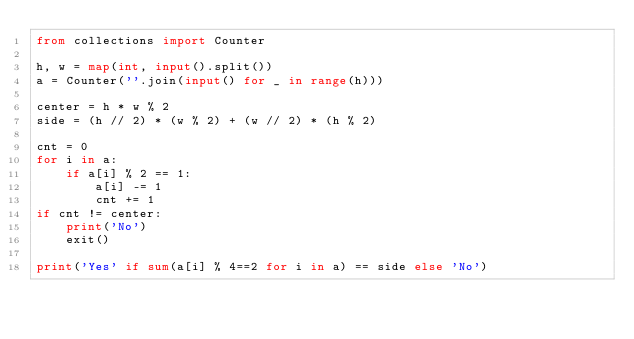Convert code to text. <code><loc_0><loc_0><loc_500><loc_500><_Python_>from collections import Counter

h, w = map(int, input().split())
a = Counter(''.join(input() for _ in range(h)))

center = h * w % 2
side = (h // 2) * (w % 2) + (w // 2) * (h % 2)

cnt = 0
for i in a:
    if a[i] % 2 == 1:
        a[i] -= 1
        cnt += 1
if cnt != center:
    print('No')
    exit()

print('Yes' if sum(a[i] % 4==2 for i in a) == side else 'No')
</code> 